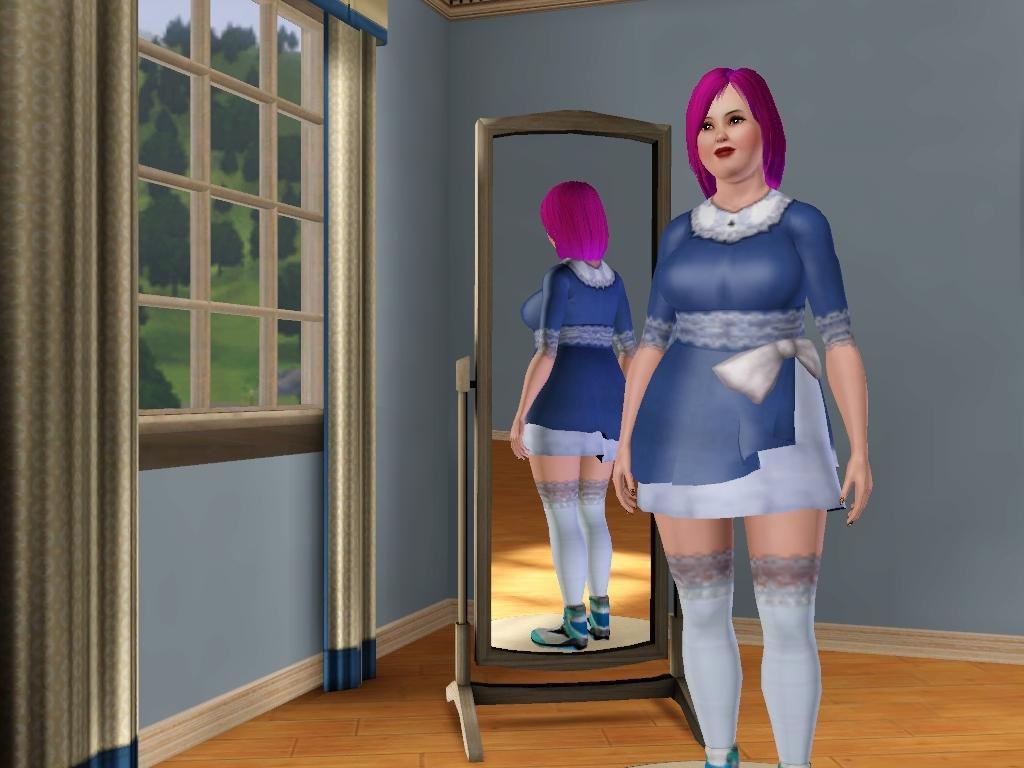How would you summarize this image in a sentence or two? This is an animated image, in this picture there is a woman standing in the floor, behind her we can see mirror, on this mirror we can see reflection of a woman. In the background of the image we can see wall, glass window and curtains, through glass windows we can see grass, trees and sky. 